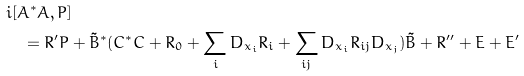<formula> <loc_0><loc_0><loc_500><loc_500>& i [ A ^ { * } A , P ] \\ & \quad = R ^ { \prime } P + \tilde { B } ^ { * } ( C ^ { * } C + R _ { 0 } + \sum _ { i } D _ { x _ { i } } R _ { i } + \sum _ { i j } D _ { x _ { i } } R _ { i j } D _ { x _ { j } } ) \tilde { B } + R ^ { \prime \prime } + E + E ^ { \prime }</formula> 